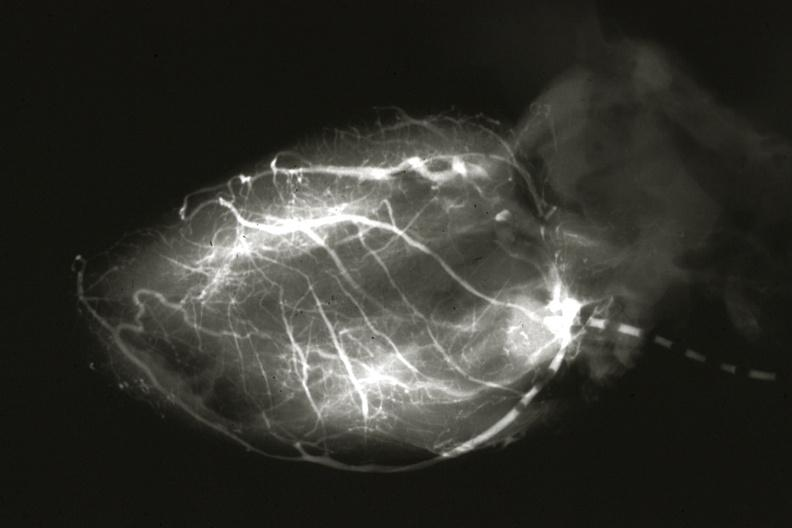s retroperitoneal leiomyosarcoma present?
Answer the question using a single word or phrase. No 